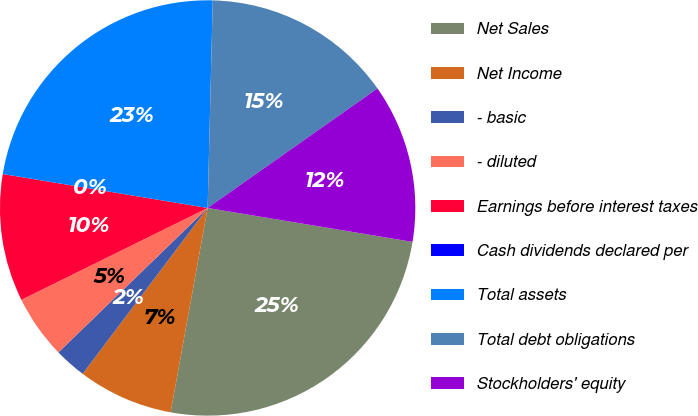Convert chart to OTSL. <chart><loc_0><loc_0><loc_500><loc_500><pie_chart><fcel>Net Sales<fcel>Net Income<fcel>- basic<fcel>- diluted<fcel>Earnings before interest taxes<fcel>Cash dividends declared per<fcel>Total assets<fcel>Total debt obligations<fcel>Stockholders' equity<nl><fcel>25.24%<fcel>7.43%<fcel>2.48%<fcel>4.95%<fcel>9.9%<fcel>0.01%<fcel>22.77%<fcel>14.85%<fcel>12.37%<nl></chart> 